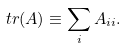<formula> <loc_0><loc_0><loc_500><loc_500>t r ( A ) \equiv \sum _ { i } A _ { i i } .</formula> 